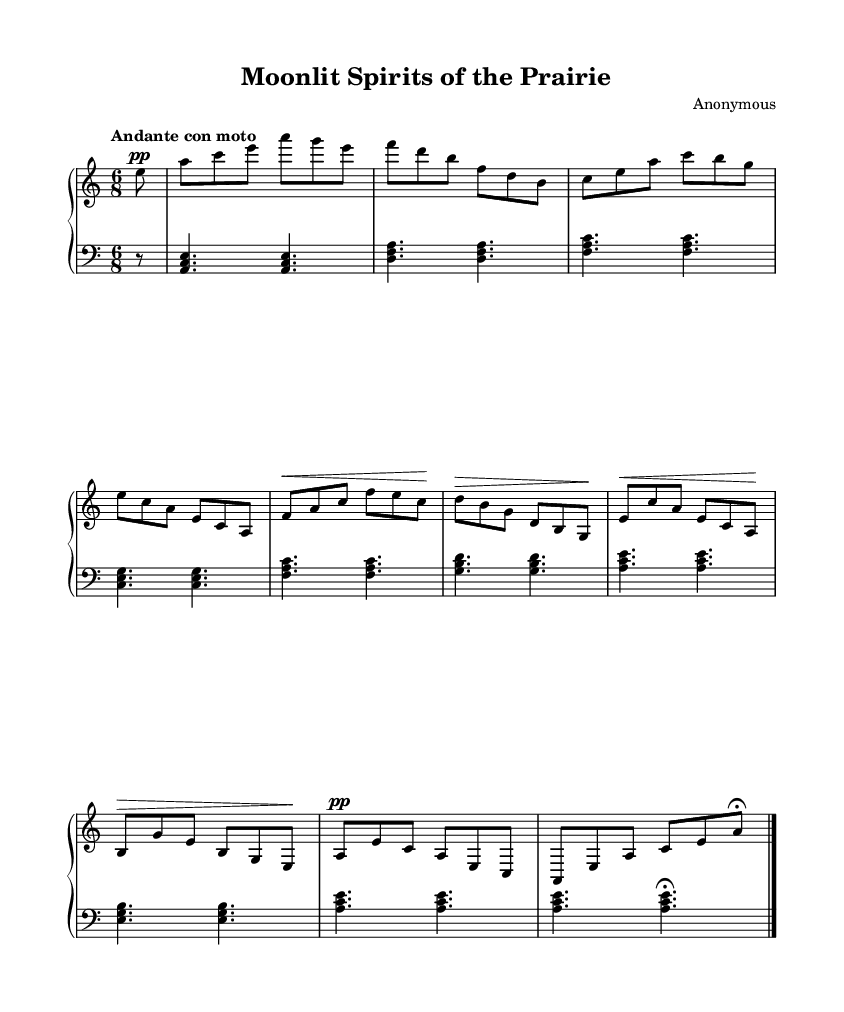What is the key signature of this music? The key signature shows an 'A' in the key signature that has no sharps or flats, indicating it is in A minor.
Answer: A minor What is the time signature of the piece? The time signature is located at the beginning of the staff and shows 6 over 8, indicating a compound time signature that features six eighth notes per measure.
Answer: 6/8 What is the tempo marking? The tempo marking is found near the beginning of the sheet music, indicating the desired speed: "Andante con moto," which suggests a moderately slow tempo with movement.
Answer: Andante con moto How many measures are present in the upper staff? Counting the measures in the upper staff shows that there are a total of eight measures throughout the piece.
Answer: 8 What dynamic markings are indicated in the upper part? The dynamic markings include 'pp' at the beginning, indicating piano (soft), and 'fermata' at the end denotes a prolonged note.
Answer: pp, fermata What is the final note of the piece? The final note's position is indicated in the upper staff with a fermata marking above it, which is an 'A' note, suggesting it is meant to be held longer.
Answer: A What type of musical form does this nocturne most likely follow? The structure and flow, characterized by lyrical melodies and variations in dynamics, suggest it follows a ternary form, common in Romantic nocturnes.
Answer: Ternary 